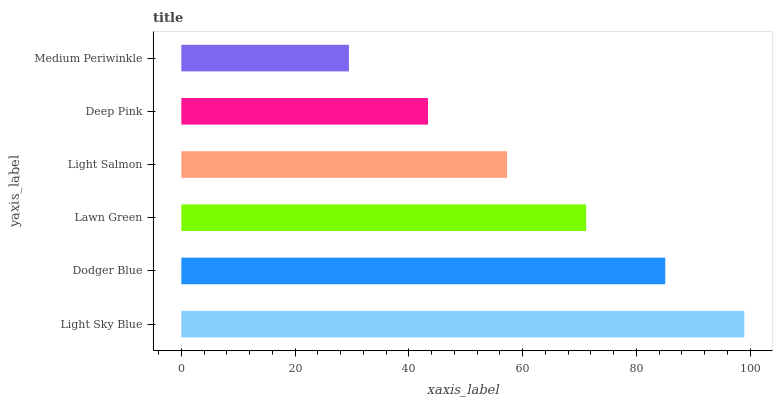Is Medium Periwinkle the minimum?
Answer yes or no. Yes. Is Light Sky Blue the maximum?
Answer yes or no. Yes. Is Dodger Blue the minimum?
Answer yes or no. No. Is Dodger Blue the maximum?
Answer yes or no. No. Is Light Sky Blue greater than Dodger Blue?
Answer yes or no. Yes. Is Dodger Blue less than Light Sky Blue?
Answer yes or no. Yes. Is Dodger Blue greater than Light Sky Blue?
Answer yes or no. No. Is Light Sky Blue less than Dodger Blue?
Answer yes or no. No. Is Lawn Green the high median?
Answer yes or no. Yes. Is Light Salmon the low median?
Answer yes or no. Yes. Is Light Salmon the high median?
Answer yes or no. No. Is Medium Periwinkle the low median?
Answer yes or no. No. 